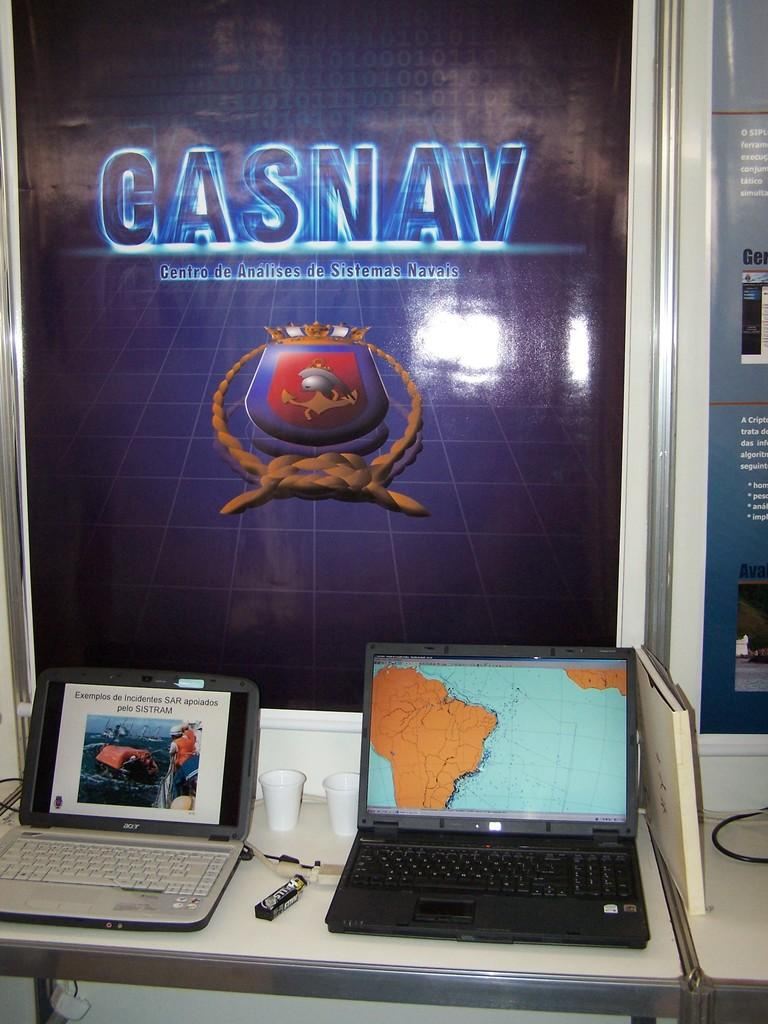<image>
Provide a brief description of the given image. the word gasnav that is on a sign 